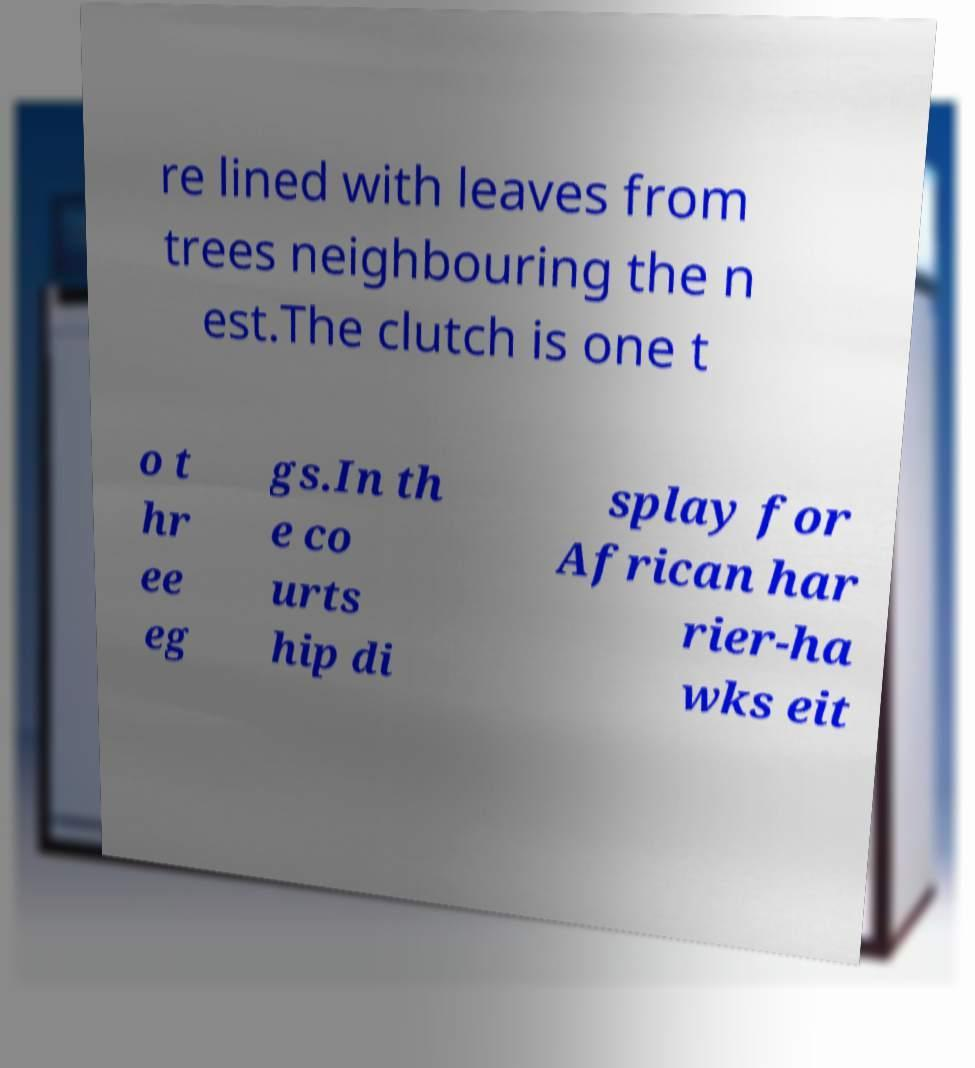For documentation purposes, I need the text within this image transcribed. Could you provide that? re lined with leaves from trees neighbouring the n est.The clutch is one t o t hr ee eg gs.In th e co urts hip di splay for African har rier-ha wks eit 